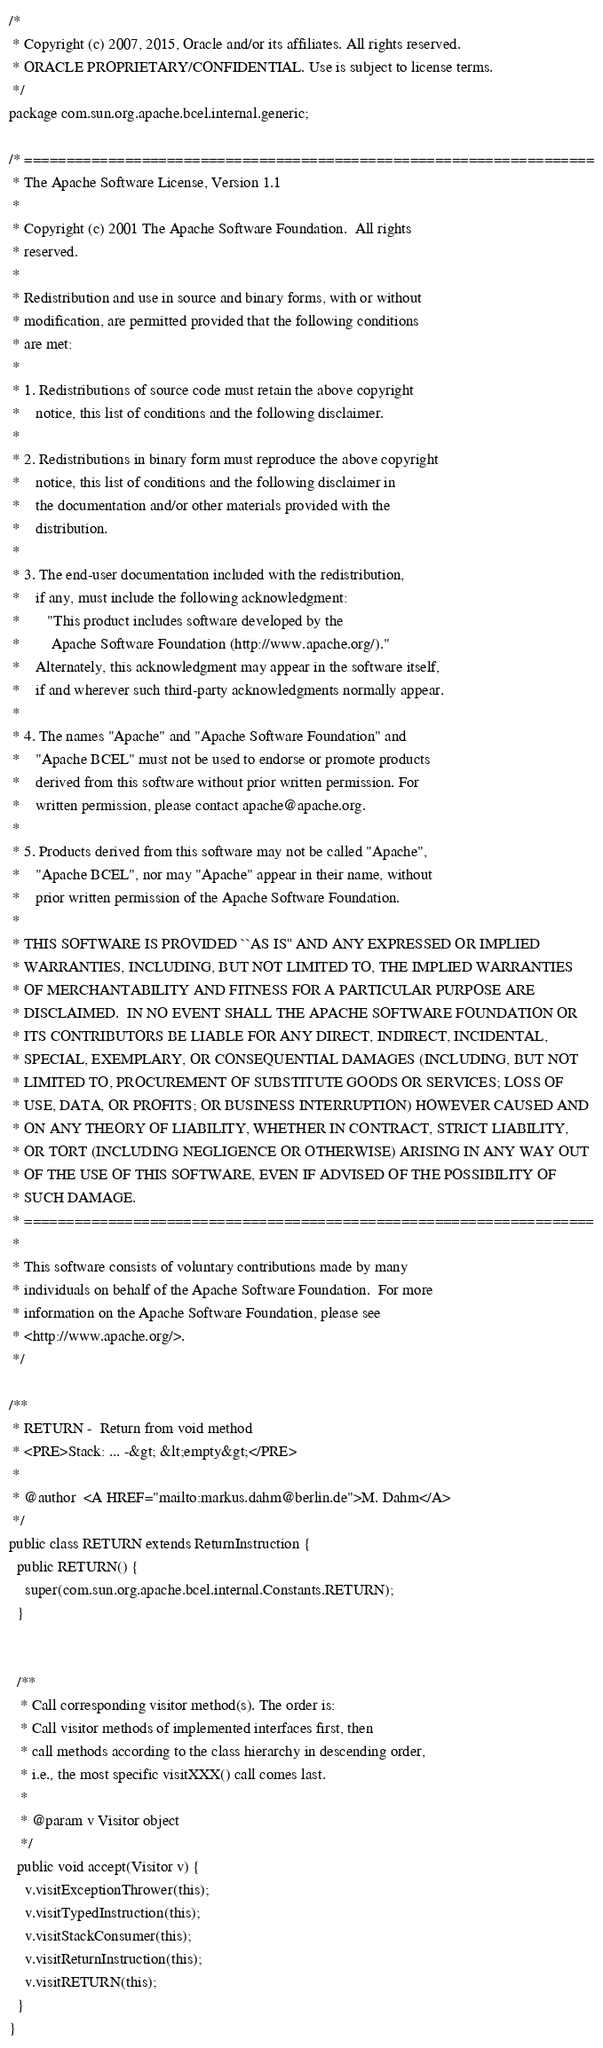<code> <loc_0><loc_0><loc_500><loc_500><_Java_>/*
 * Copyright (c) 2007, 2015, Oracle and/or its affiliates. All rights reserved.
 * ORACLE PROPRIETARY/CONFIDENTIAL. Use is subject to license terms.
 */
package com.sun.org.apache.bcel.internal.generic;

/* ====================================================================
 * The Apache Software License, Version 1.1
 *
 * Copyright (c) 2001 The Apache Software Foundation.  All rights
 * reserved.
 *
 * Redistribution and use in source and binary forms, with or without
 * modification, are permitted provided that the following conditions
 * are met:
 *
 * 1. Redistributions of source code must retain the above copyright
 *    notice, this list of conditions and the following disclaimer.
 *
 * 2. Redistributions in binary form must reproduce the above copyright
 *    notice, this list of conditions and the following disclaimer in
 *    the documentation and/or other materials provided with the
 *    distribution.
 *
 * 3. The end-user documentation included with the redistribution,
 *    if any, must include the following acknowledgment:
 *       "This product includes software developed by the
 *        Apache Software Foundation (http://www.apache.org/)."
 *    Alternately, this acknowledgment may appear in the software itself,
 *    if and wherever such third-party acknowledgments normally appear.
 *
 * 4. The names "Apache" and "Apache Software Foundation" and
 *    "Apache BCEL" must not be used to endorse or promote products
 *    derived from this software without prior written permission. For
 *    written permission, please contact apache@apache.org.
 *
 * 5. Products derived from this software may not be called "Apache",
 *    "Apache BCEL", nor may "Apache" appear in their name, without
 *    prior written permission of the Apache Software Foundation.
 *
 * THIS SOFTWARE IS PROVIDED ``AS IS'' AND ANY EXPRESSED OR IMPLIED
 * WARRANTIES, INCLUDING, BUT NOT LIMITED TO, THE IMPLIED WARRANTIES
 * OF MERCHANTABILITY AND FITNESS FOR A PARTICULAR PURPOSE ARE
 * DISCLAIMED.  IN NO EVENT SHALL THE APACHE SOFTWARE FOUNDATION OR
 * ITS CONTRIBUTORS BE LIABLE FOR ANY DIRECT, INDIRECT, INCIDENTAL,
 * SPECIAL, EXEMPLARY, OR CONSEQUENTIAL DAMAGES (INCLUDING, BUT NOT
 * LIMITED TO, PROCUREMENT OF SUBSTITUTE GOODS OR SERVICES; LOSS OF
 * USE, DATA, OR PROFITS; OR BUSINESS INTERRUPTION) HOWEVER CAUSED AND
 * ON ANY THEORY OF LIABILITY, WHETHER IN CONTRACT, STRICT LIABILITY,
 * OR TORT (INCLUDING NEGLIGENCE OR OTHERWISE) ARISING IN ANY WAY OUT
 * OF THE USE OF THIS SOFTWARE, EVEN IF ADVISED OF THE POSSIBILITY OF
 * SUCH DAMAGE.
 * ====================================================================
 *
 * This software consists of voluntary contributions made by many
 * individuals on behalf of the Apache Software Foundation.  For more
 * information on the Apache Software Foundation, please see
 * <http://www.apache.org/>.
 */

/**
 * RETURN -  Return from void method
 * <PRE>Stack: ... -&gt; &lt;empty&gt;</PRE>
 *
 * @author  <A HREF="mailto:markus.dahm@berlin.de">M. Dahm</A>
 */
public class RETURN extends ReturnInstruction {
  public RETURN() {
    super(com.sun.org.apache.bcel.internal.Constants.RETURN);
  }


  /**
   * Call corresponding visitor method(s). The order is:
   * Call visitor methods of implemented interfaces first, then
   * call methods according to the class hierarchy in descending order,
   * i.e., the most specific visitXXX() call comes last.
   *
   * @param v Visitor object
   */
  public void accept(Visitor v) {
    v.visitExceptionThrower(this);
    v.visitTypedInstruction(this);
    v.visitStackConsumer(this);
    v.visitReturnInstruction(this);
    v.visitRETURN(this);
  }
}
</code> 